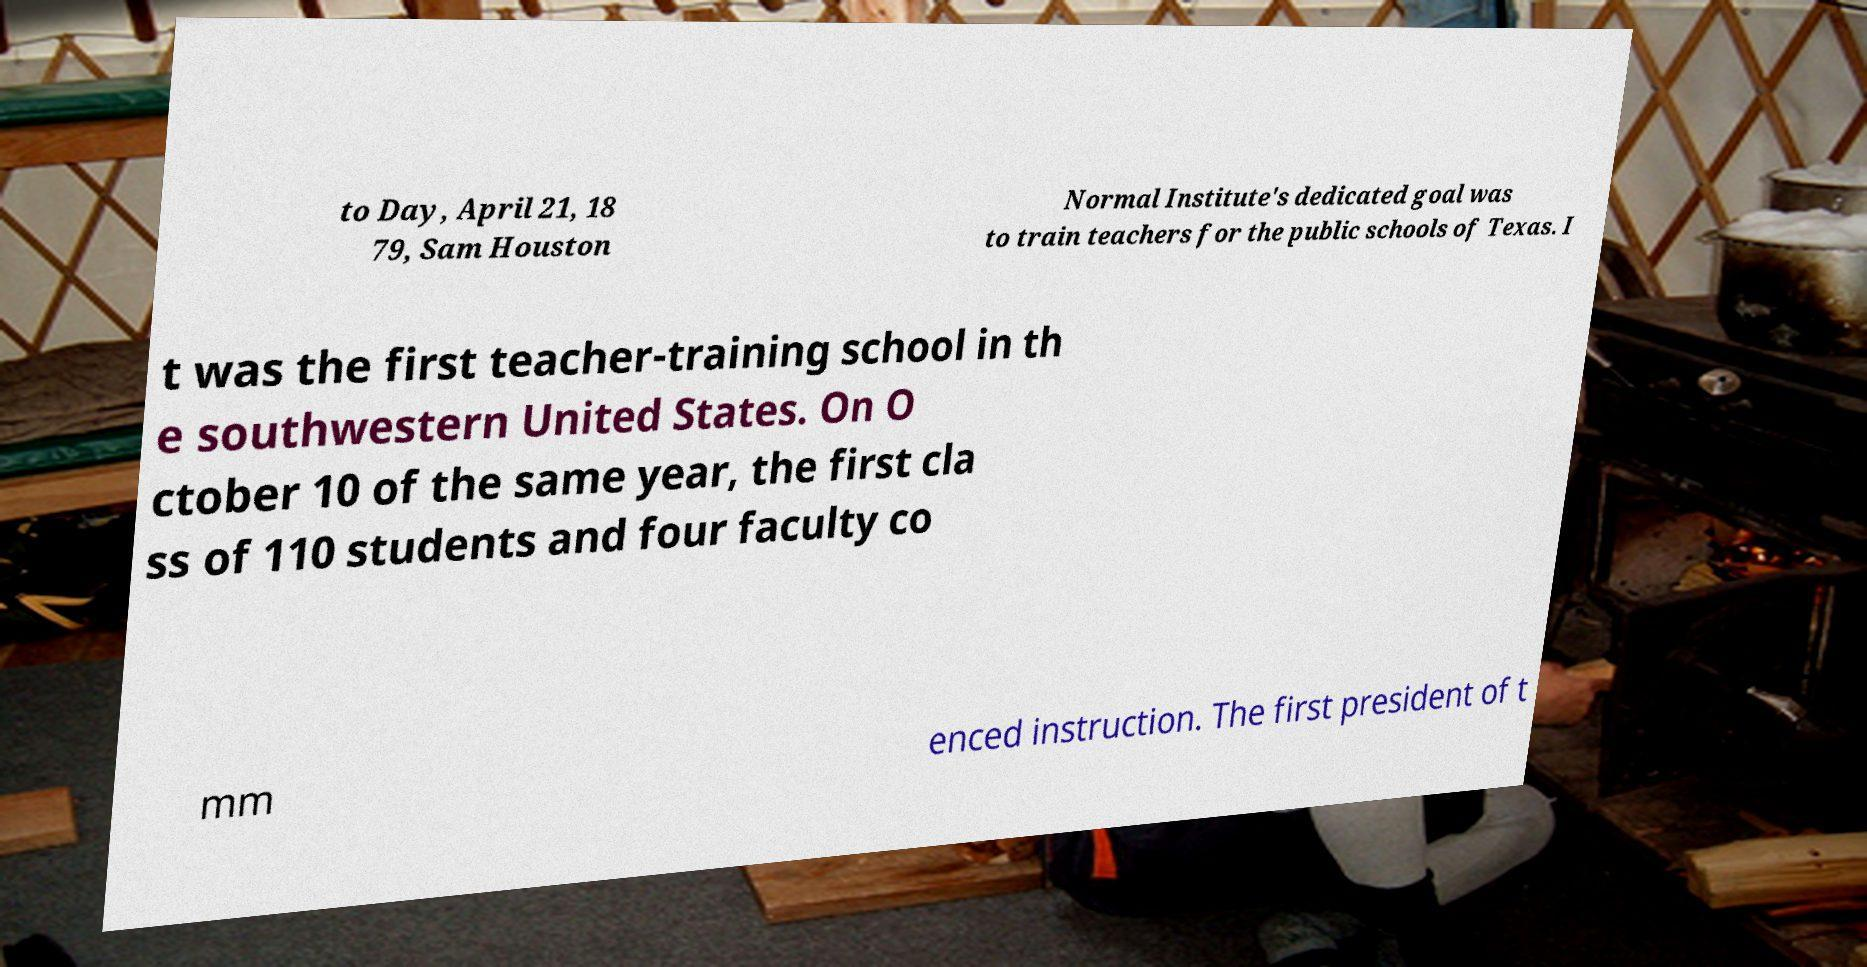Could you assist in decoding the text presented in this image and type it out clearly? to Day, April 21, 18 79, Sam Houston Normal Institute's dedicated goal was to train teachers for the public schools of Texas. I t was the first teacher-training school in th e southwestern United States. On O ctober 10 of the same year, the first cla ss of 110 students and four faculty co mm enced instruction. The first president of t 